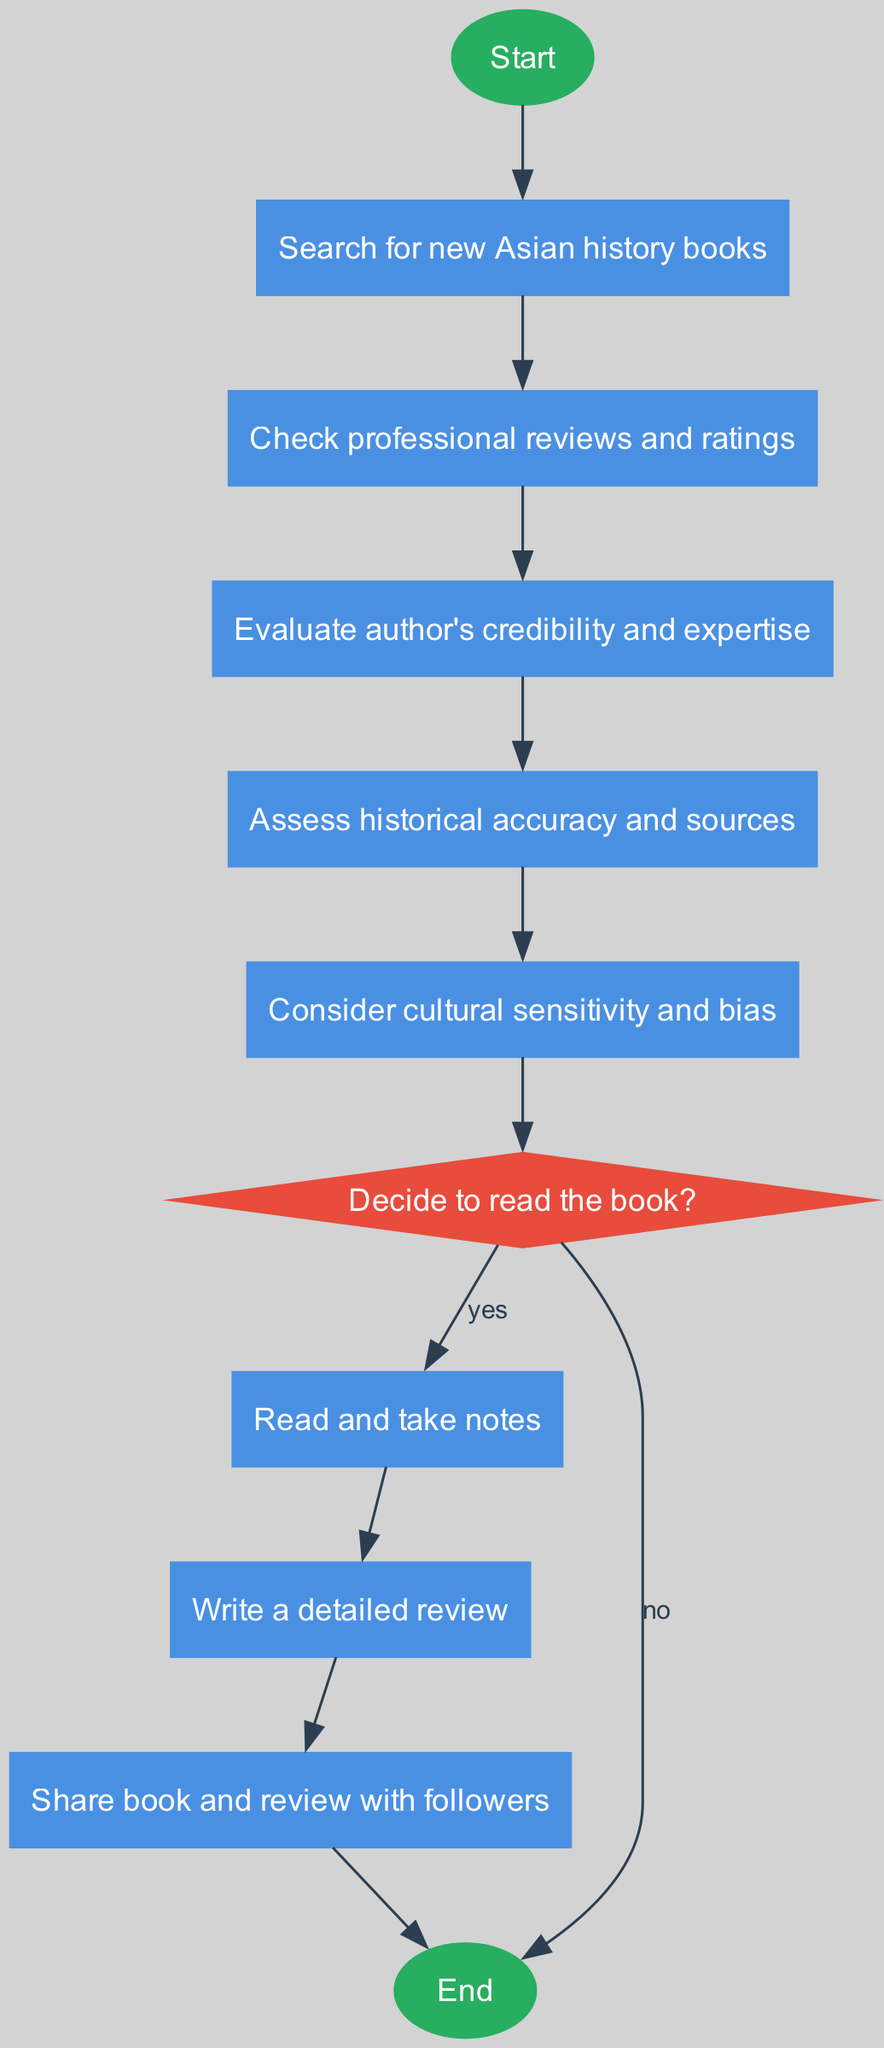What is the first step in the decision-making process? The first step in the process is represented by the "Start" node, which initiates the flowchart. From "Start", the next node indicates to "Search for new Asian history books."
Answer: Start How many main decision points are in the flowchart? The flowchart has one main decision point, which is represented by the "Decide to read the book?" diamond node.
Answer: One What do you check after searching for new books? After searching for new books, you check "professional reviews and ratings," which is the next node in the sequence.
Answer: Check professional reviews and ratings What happens if you decide not to read the book? If you decide not to read the book, the flowchart indicates to end the process directly from the "Decide" node, connecting to the "End" node.
Answer: End Which factor comes before assessing historical accuracy? Before assessing historical accuracy, you must consider cultural sensitivity and bias, which occurs within the sequence of decisions leading to that assessment.
Answer: Consider cultural sensitivity and bias What action is taken after writing a detailed review? After writing a detailed review, the next action indicated in the flowchart is to "Share the book and review with followers." This follows in the flow of actions.
Answer: Share book and review with followers Which node represents evaluating the author's credibility? The node that represents evaluating the author's credibility is labeled as "Evaluate author's credibility and expertise," which connects the previous action of checking reviews.
Answer: Evaluate author's credibility and expertise What is the consequence of evaluating historical accuracy? The consequence of evaluating historical accuracy is the subsequent assessment of cultural sensitivity and bias, which is directly connected in the flow sequence after that evaluation.
Answer: Consider cultural sensitivity and bias How many nodes lead to the final action of sharing? There are four nodes that lead to the final action of sharing: "Read and take notes," "Write a detailed review," and "Share book and review with followers."
Answer: Four 